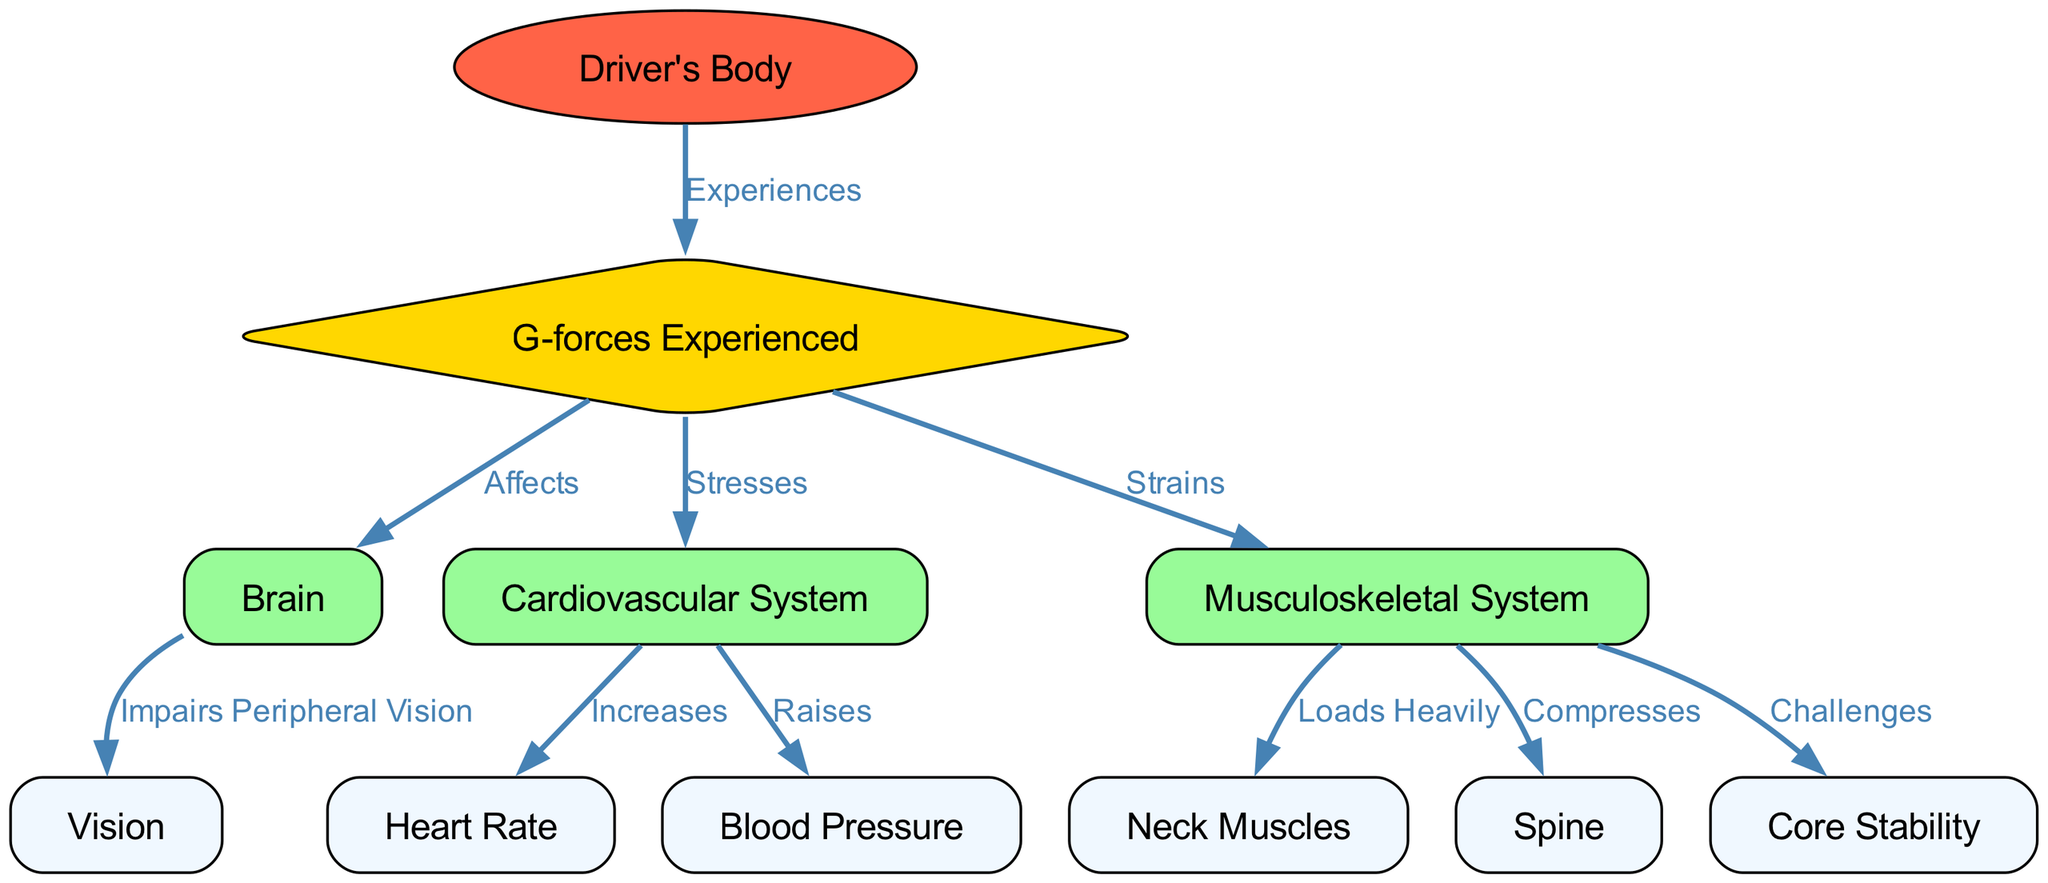What is the main component of the diagram? The main component is the "Driver's Body," which is the central focus of the diagram, representing the physiological response of a Formula 1 driver during a race.
Answer: Driver's Body How many nodes are there in the diagram? By counting the unique nodes listed in the diagram, I find there are eleven nodes that represent various systems and components in relation to the driver's body and the G-forces experienced.
Answer: Eleven Which node affects the Brain? The node "G-forces Experienced" affects the "Brain," indicating that the forces experienced by the driver have a direct impact on brain function.
Answer: G-forces Experienced What does the Musculoskeletal System strain? According to the diagram, the "Musculoskeletal System" strains the "Neck Muscles," indicating that the driver experiences strain in their neck due to G-forces during the race.
Answer: Neck Muscles How does the Cardiovascular System respond to G-forces? The diagram shows that the "Cardiovascular System" stresses under G-forces, which leads to an increase in "Heart Rate" and a raise in "Blood Pressure." This illustrates how G-forces impact the cardiovascular response of the driver.
Answer: Stresses What happens to Vision when G-forces affect the Brain? The diagram indicates that the impact on the Brain due to G-forces impairs Peripheral Vision, which is crucial for a driver to have a clear view of their surroundings on the track.
Answer: Impairs Peripheral Vision What does the Musculoskeletal System challenge? The "Musculoskeletal System" challenges "Core Stability," suggesting that the physical demands of G-forces put the driver’s core stability to the test during racing.
Answer: Core Stability Which node is loaded heavily by the Musculoskeletal System? According to the diagram, the "Neck Muscles" are heavily loaded by the "Musculoskeletal System," indicating the stress and demands placed specifically on the neck during high G-force situations.
Answer: Neck Muscles What does an increase in Heart Rate lead to according to the diagram? The diagram connects an increase in "Heart Rate" with the "Cardiovascular System," which suggests that G-forces lead to heightened heart activity, a physiological response to stress.
Answer: Increases 